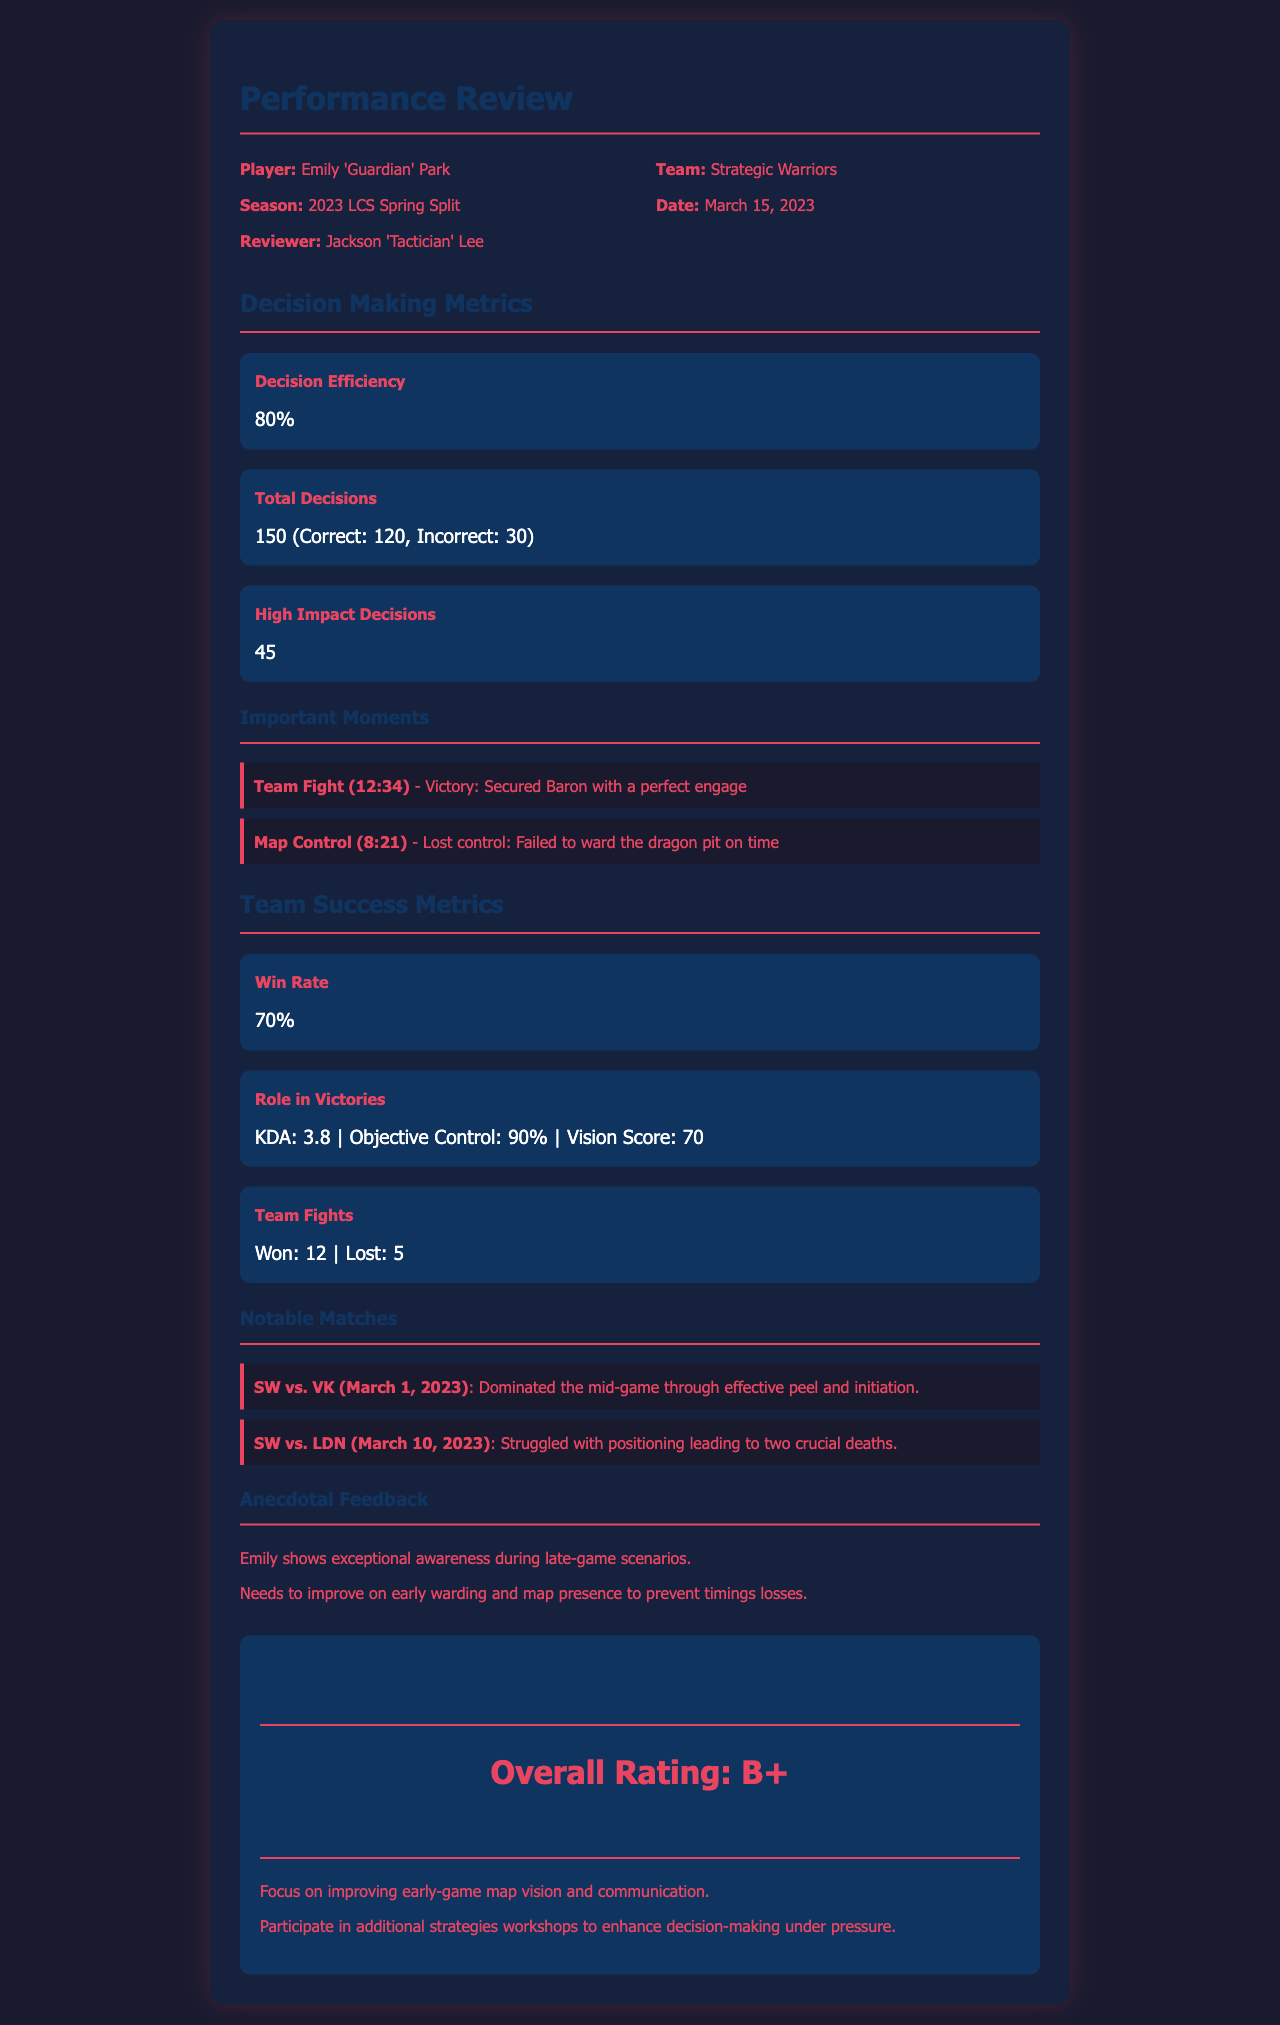What is the player's name? The player's name is listed under the header "Player" in the document.
Answer: Emily 'Guardian' Park What is the Decision Efficiency percentage? The Decision Efficiency metric is shown in the "Decision Making Metrics" section of the document.
Answer: 80% How many Total Decisions were made? The Total Decisions metric is also located in the "Decision Making Metrics" section.
Answer: 150 (Correct: 120, Incorrect: 30) What is the Win Rate reported? The Win Rate metric is under "Team Success Metrics" in the document.
Answer: 70% Which notable match showed Emily's struggle with positioning? The details of the notable matches are listed, specifically indicating her struggles in one of the matches.
Answer: SW vs. LDN (March 10, 2023) What was Emily's KDA in Role in Victories? The Role in Victories metric mentions the KDA in the document.
Answer: 3.8 How many High Impact Decisions were made? The High Impact Decisions metric is present under "Decision Making Metrics".
Answer: 45 What is the Overall Rating given to Emily? The Overall Rating is mentioned in the conclusion section of the document.
Answer: B+ What recommendation is made for Emily regarding early-game play? Recommendations for Emily are provided in the conclusion section, specifically for early-game improvement.
Answer: Focus on improving early-game map vision and communication 